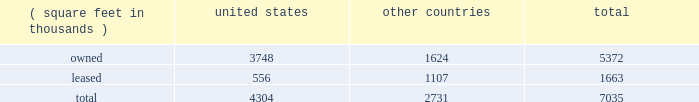Item 2 : properties information concerning applied's properties at october 25 , 2015 is set forth below: .
Because of the interrelation of applied's operations , properties within a country may be shared by the segments operating within that country .
The company's headquarters offices are in santa clara , california .
Products in silicon systems are manufactured in austin , texas ; gloucester , massachusetts ; rehovot , israel ; and singapore .
Remanufactured equipment products in the applied global services segment are produced primarily in austin , texas .
Products in the display segment are manufactured in tainan , taiwan and santa clara , california .
Products in the energy and environmental solutions segment are primarily manufactured in alzenau , germany and treviso , italy .
Applied also owns and leases offices , plants and warehouse locations in many locations throughout the world , including in europe , japan , north america ( principally the united states ) , israel , china , india , korea , southeast asia and taiwan .
These facilities are principally used for manufacturing ; research , development and engineering ; and marketing , sales and customer support .
Applied also owns a total of approximately 139 acres of buildable land in texas , california , israel and italy that could accommodate additional building space .
Applied considers the properties that it owns or leases as adequate to meet its current and future requirements .
Applied regularly assesses the size , capability and location of its global infrastructure and periodically makes adjustments based on these assessments. .
What percentage of company's property are leased and located in united states? 
Computations: (556 / 7035)
Answer: 0.07903. 